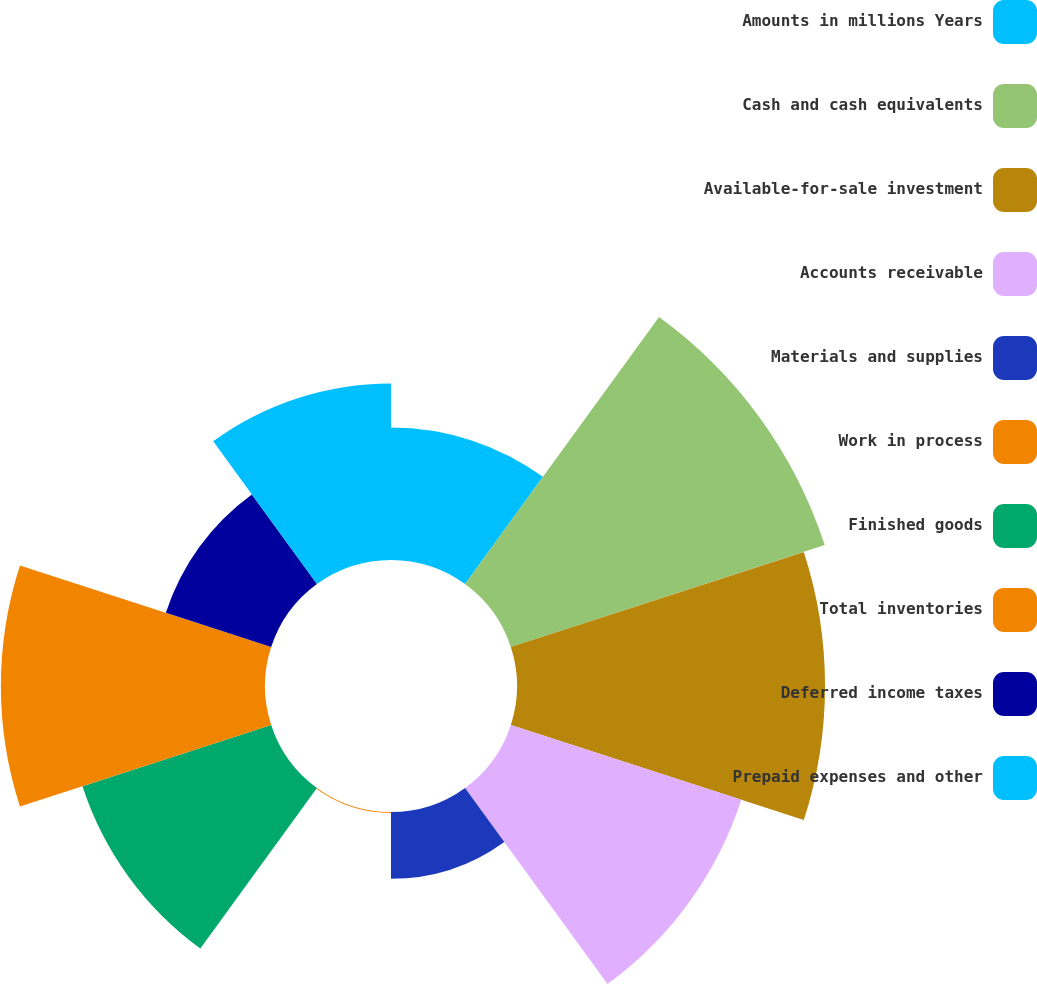Convert chart to OTSL. <chart><loc_0><loc_0><loc_500><loc_500><pie_chart><fcel>Amounts in millions Years<fcel>Cash and cash equivalents<fcel>Available-for-sale investment<fcel>Accounts receivable<fcel>Materials and supplies<fcel>Work in process<fcel>Finished goods<fcel>Total inventories<fcel>Deferred income taxes<fcel>Prepaid expenses and other<nl><fcel>7.24%<fcel>18.03%<fcel>16.83%<fcel>13.24%<fcel>3.65%<fcel>0.05%<fcel>10.84%<fcel>14.43%<fcel>6.05%<fcel>9.64%<nl></chart> 